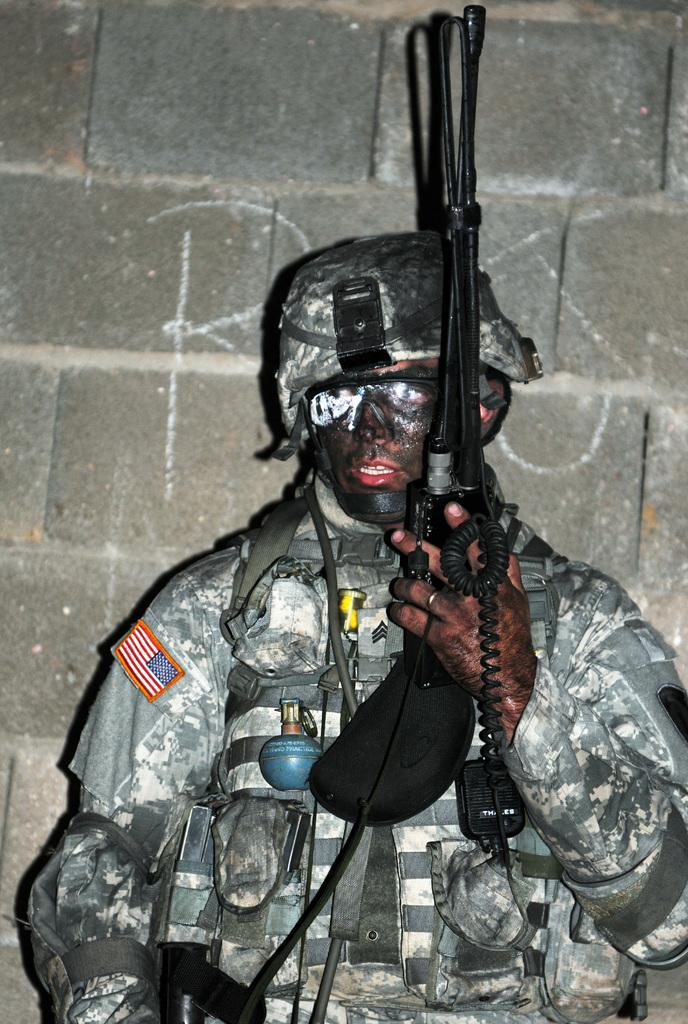What is the main subject of the image? There is a person in the image. What is the person doing in the image? The person is holding an object. What can be seen in the background of the image? There is a wall in the background of the image. What type of chain can be seen hanging from the person's neck in the image? There is no chain visible in the image; the person is holding an object, but there is no mention of a chain. 